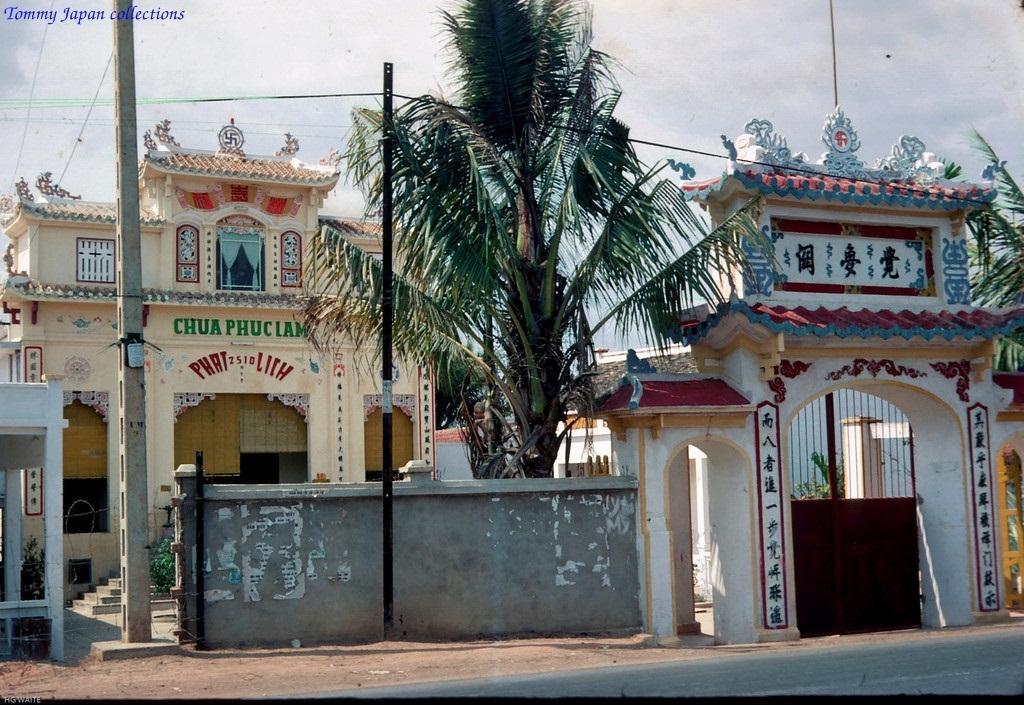Please provide a concise description of this image. In this image in the center there is one building and on the right side there are some houses, gate, wall and in the center there is one pole. And also in the center there is one tree and some wires, at the bottom there is a road. On the top of the image there is sky. 